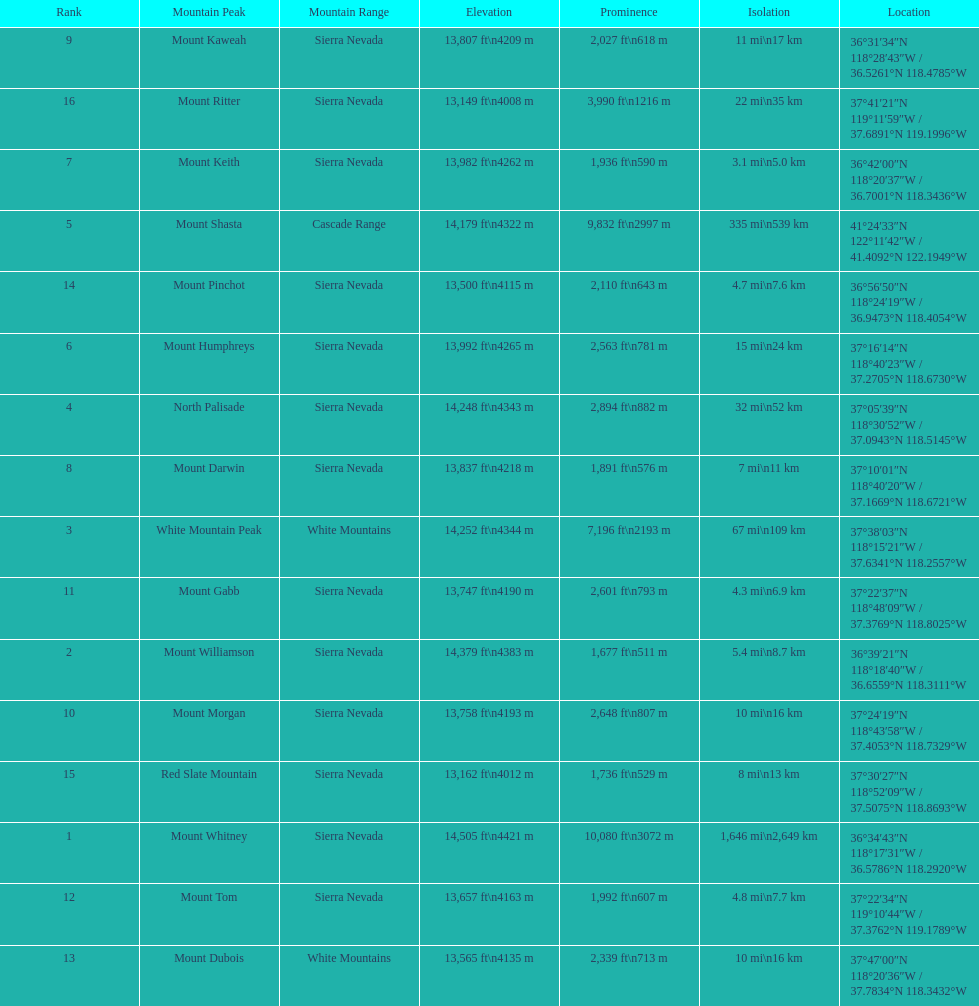How much taller is the mountain peak of mount williamson than that of mount keith? 397 ft. 